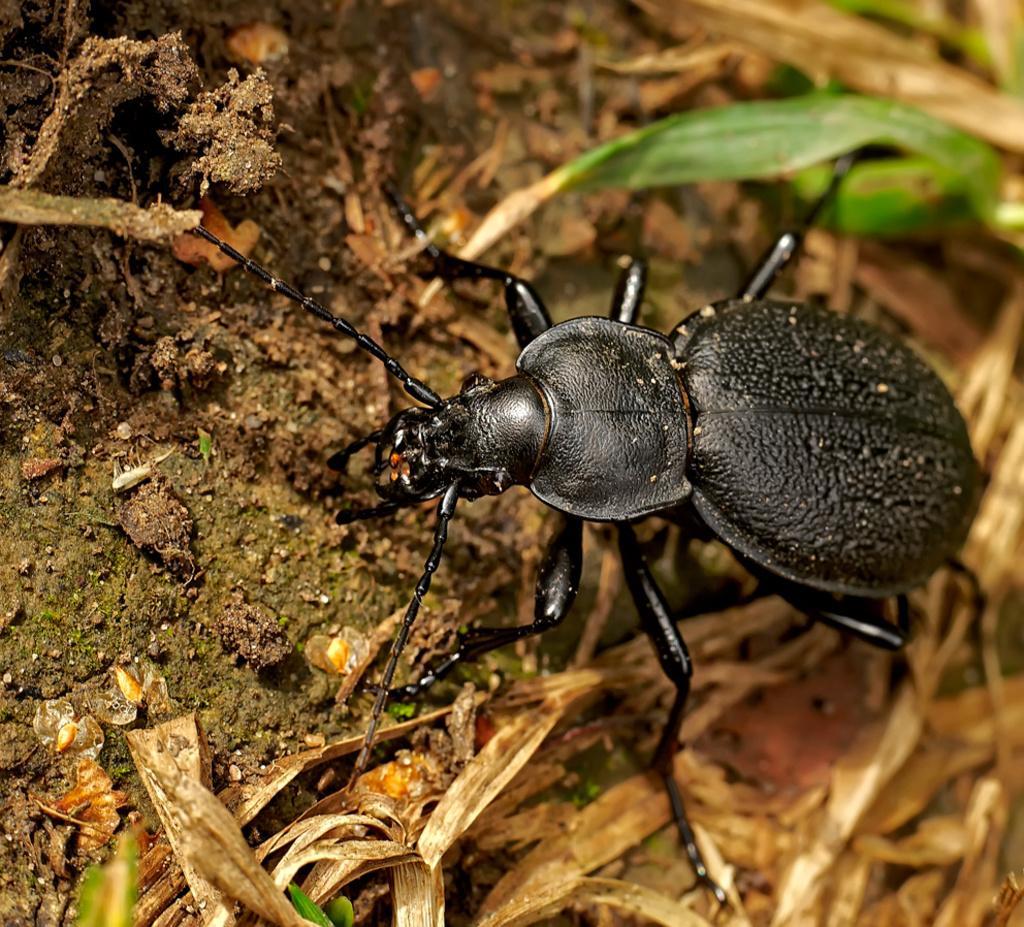Please provide a concise description of this image. Here in this picture we can see a dung beetle present on the ground over there and beside it we can see some grass present over there. 